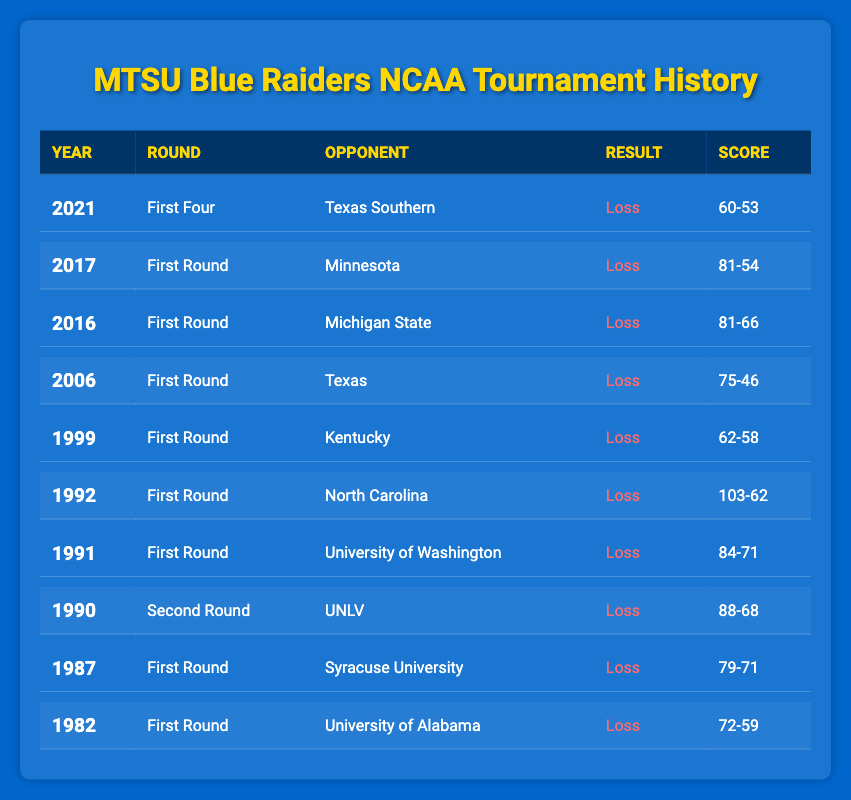What year did MTSU first participate in the NCAA tournament? In the table, the earliest year mentioned for MTSU's participation is 1982. This is the first entry listed in the data.
Answer: 1982 How many times did MTSU play in the First Round of the NCAA tournament? By reviewing the table, we can see that MTSU appeared in the First Round in the years 1982, 1987, 1991, 1992, 1999, 2006, 2016, and 2017, totaling 8 entries.
Answer: 8 In what year did MTSU have their closest loss in terms of point difference? To find the closest loss, we need to calculate the point differences for all the losses. In 1999, they lost to Kentucky by 4 points (62-58), which is smaller than any other loss.
Answer: 1999 Which opponent did MTSU face in the 2006 NCAA tournament? Looking at the data, the entry for the year 2006 shows that MTSU faced Texas in the First Round.
Answer: Texas Is it true that MTSU lost to North Carolina in the NCAA tournament? Checking the table reveals that in 1992, MTSU played against North Carolina and lost, hence the statement is true.
Answer: Yes What was the score when MTSU faced Michigan State in 2016? The table lists the result of the game against Michigan State in 2016, indicating a score of 81-66.
Answer: 81-66 How many of the tournament losses occurred in the First Round? We count the entries in the First Round: those are 1982, 1987, 1991, 1992, 1999, 2006, 2016, and 2017. That's 8 losses in total.
Answer: 8 What is the average score difference of MTSU’s NCAA tournament losses? We need to find the score differences for each loss and then average them. The differences are calculated as follows: 72-59=13, 79-71=8, 88-68=20, 84-71=13, 103-62=41, 62-58=4, 75-46=29, 81-66=15, 81-54=27, 60-53=7. The sum of these differences is 13 + 8 + 20 + 13 + 41 + 4 + 29 + 15 + 27 + 7 = 177. There are 10 losses, thus the average difference is 177 / 10 = 17.7
Answer: 17.7 